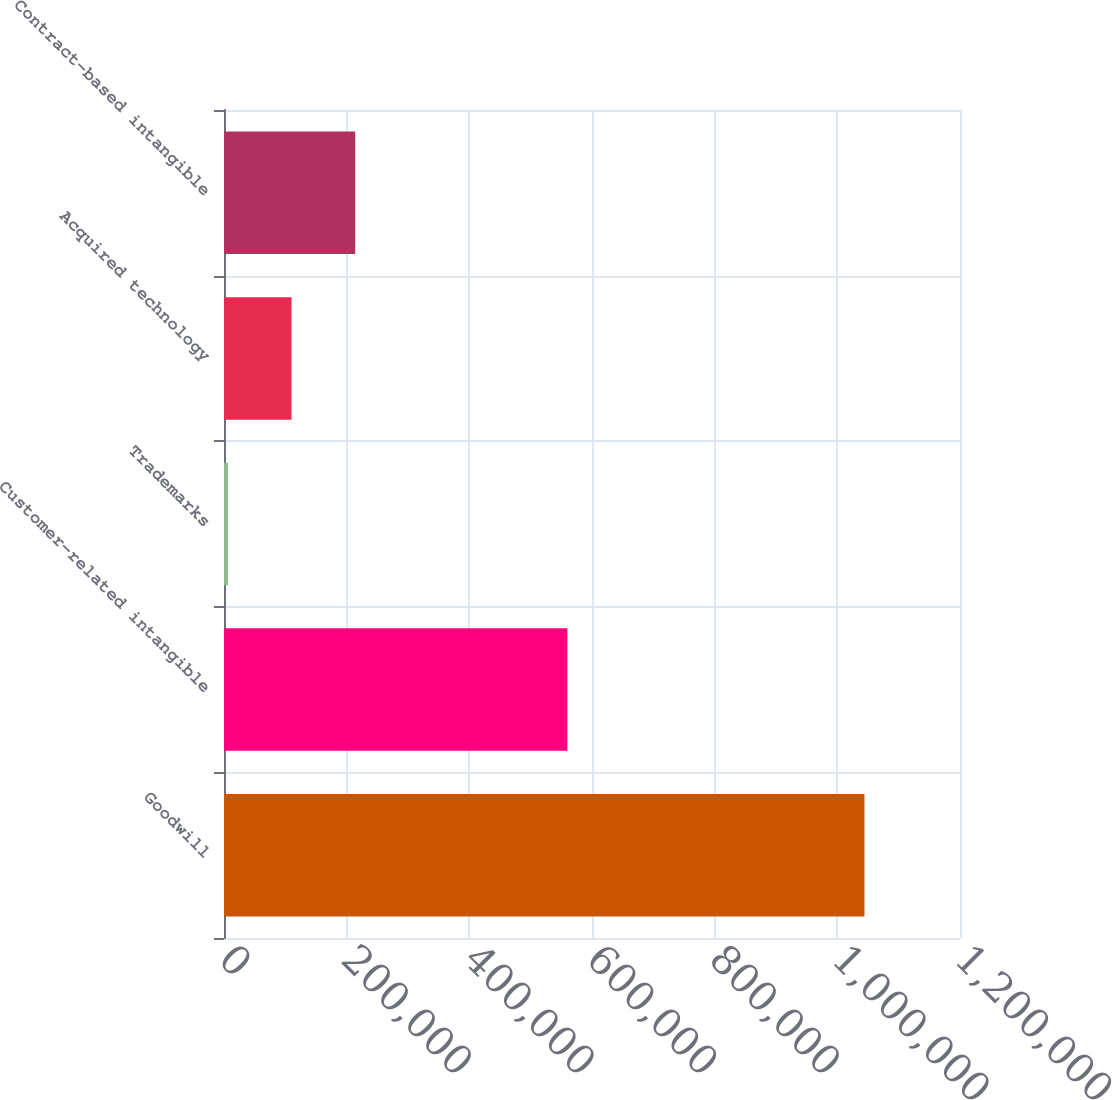Convert chart. <chart><loc_0><loc_0><loc_500><loc_500><bar_chart><fcel>Goodwill<fcel>Customer-related intangible<fcel>Trademarks<fcel>Acquired technology<fcel>Contract-based intangible<nl><fcel>1.04422e+06<fcel>559884<fcel>6390<fcel>110173<fcel>213956<nl></chart> 